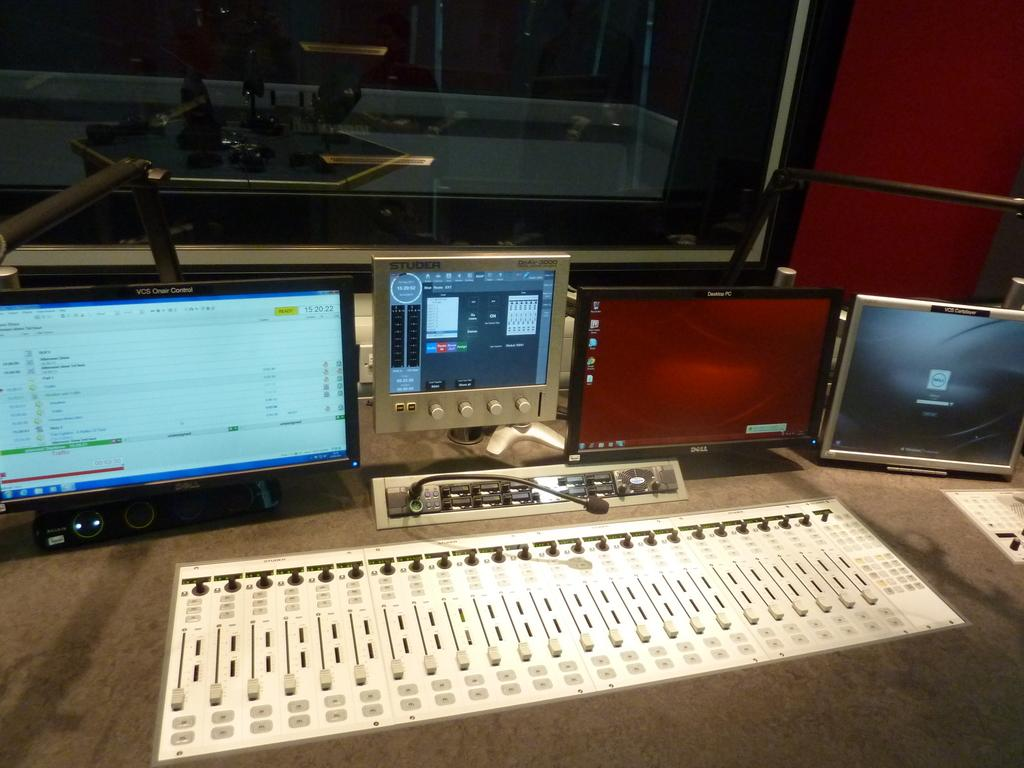<image>
Share a concise interpretation of the image provided. Different electronic screens are on a table including one labeled Studer with small knobs on the bottom of it. 